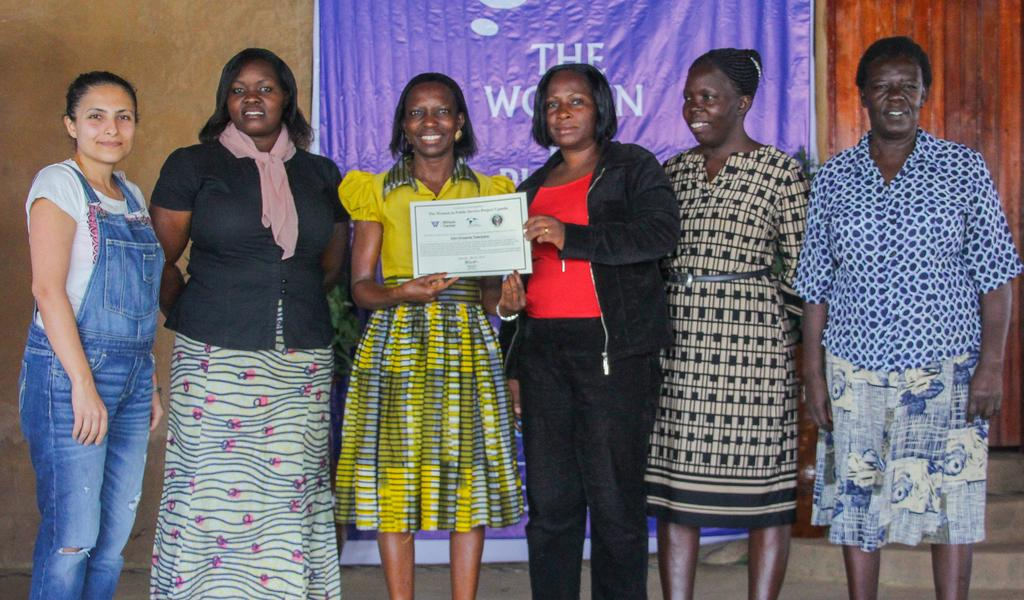What is happening in the image? There is a group of people standing in the image. Can you describe what the two women are holding? Two women are holding an object. What architectural feature can be seen in the background? There are stairs visible in the background. What is written or displayed on the banner in the background? There is a banner with text in the background. What type of apparel is the group of people wearing on their feet in the image? There is no information about the apparel or feet of the people in the image. What type of work is being performed by the flesh in the image? There is no flesh or work being performed in the image. 